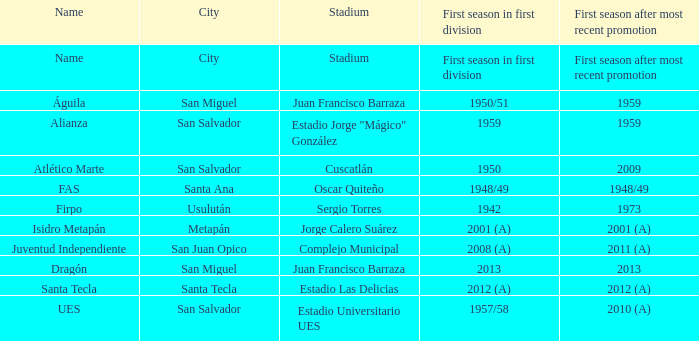Which city is Alianza? San Salvador. 